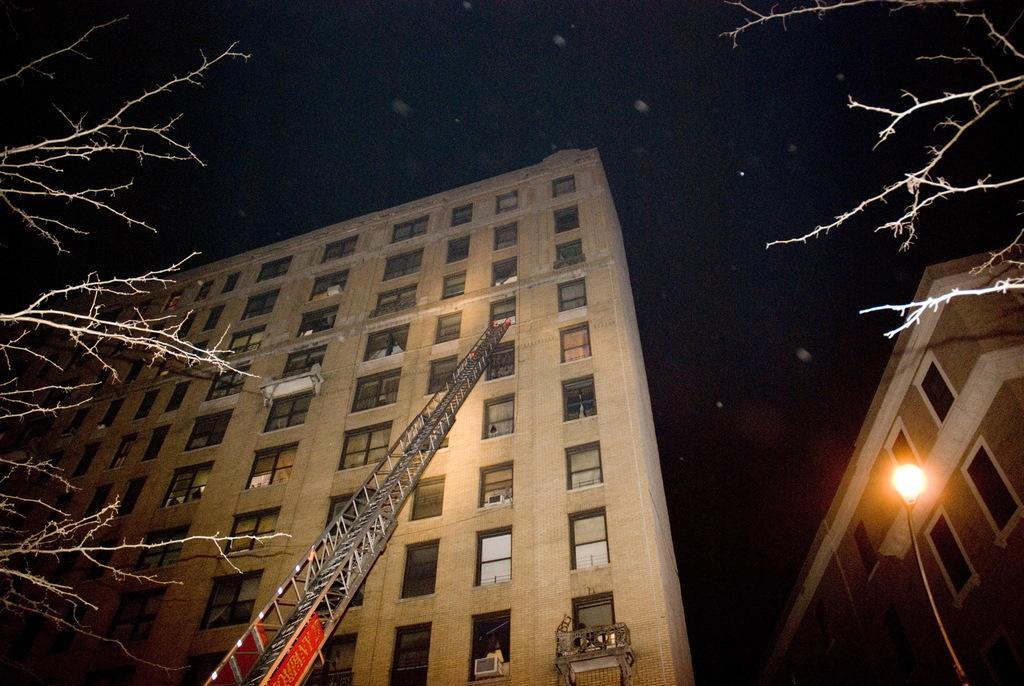How would you summarize this image in a sentence or two? In this image there are buildings. We can see glass windows. There is a metal ladder. There is a street light. There are trees on the both sides. There are stars in the sky. 